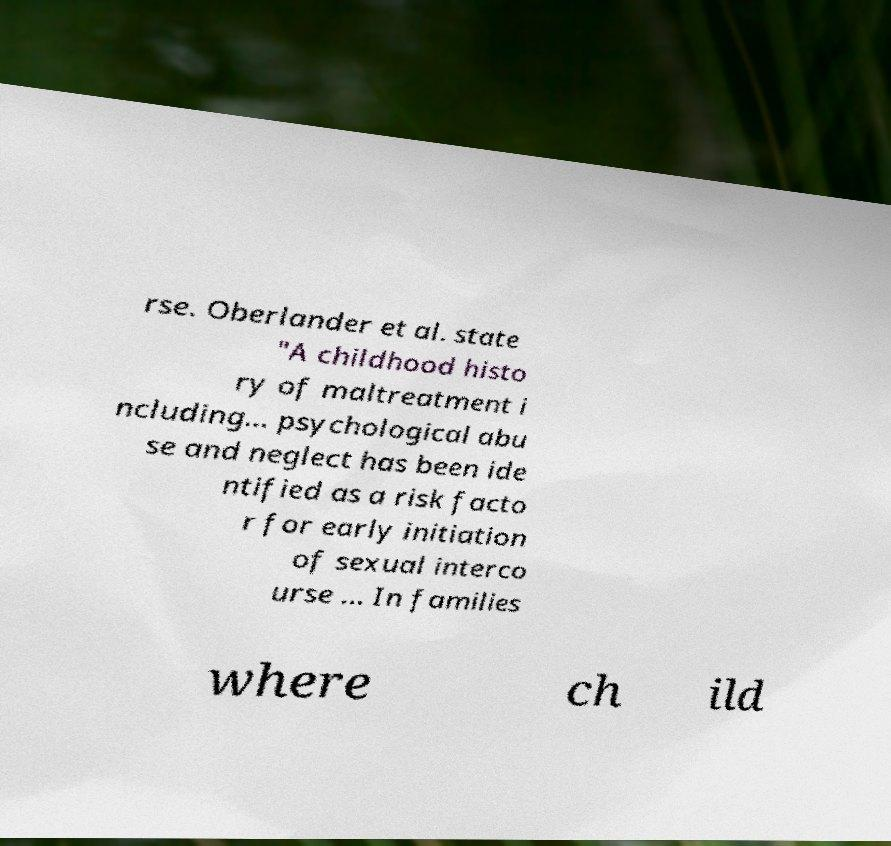What messages or text are displayed in this image? I need them in a readable, typed format. rse. Oberlander et al. state "A childhood histo ry of maltreatment i ncluding... psychological abu se and neglect has been ide ntified as a risk facto r for early initiation of sexual interco urse ... In families where ch ild 